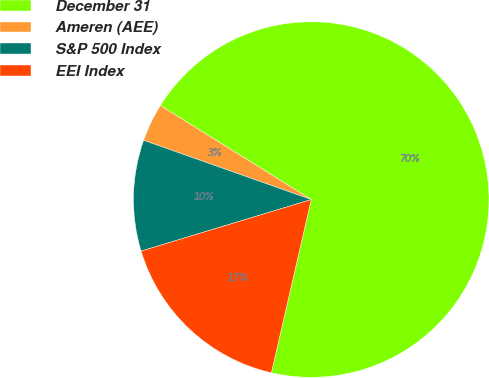Convert chart. <chart><loc_0><loc_0><loc_500><loc_500><pie_chart><fcel>December 31<fcel>Ameren (AEE)<fcel>S&P 500 Index<fcel>EEI Index<nl><fcel>69.73%<fcel>3.46%<fcel>10.09%<fcel>16.72%<nl></chart> 